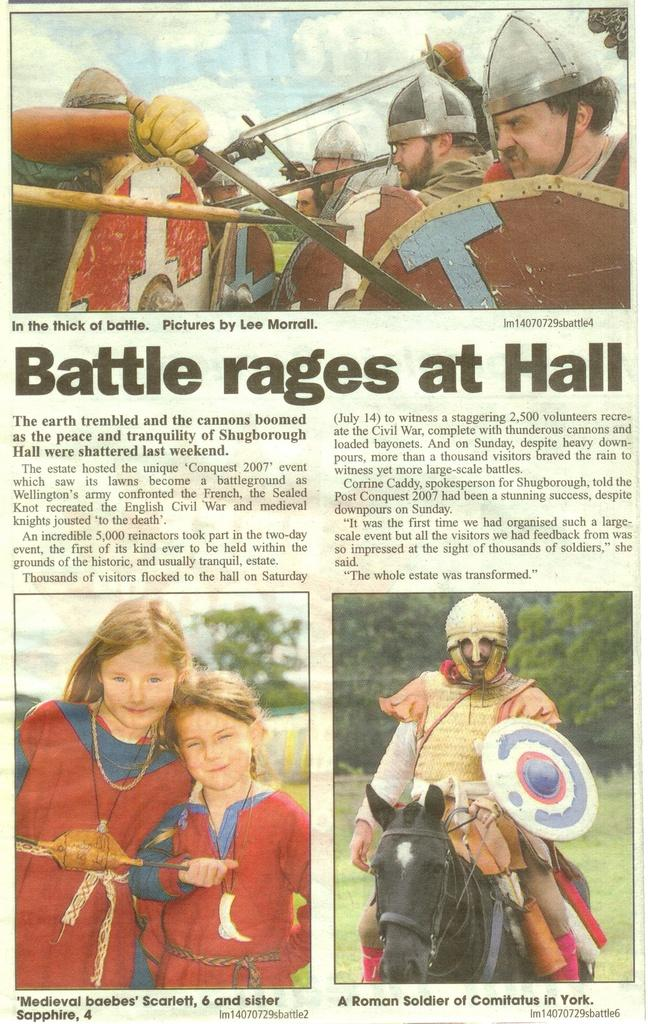What is present in the image that contains both images and text? There is a poster in the image that contains images and text. What type of glue is used to attach the celery to the base in the image? There is no celery or base present in the image; it only contains a poster with images and text. 